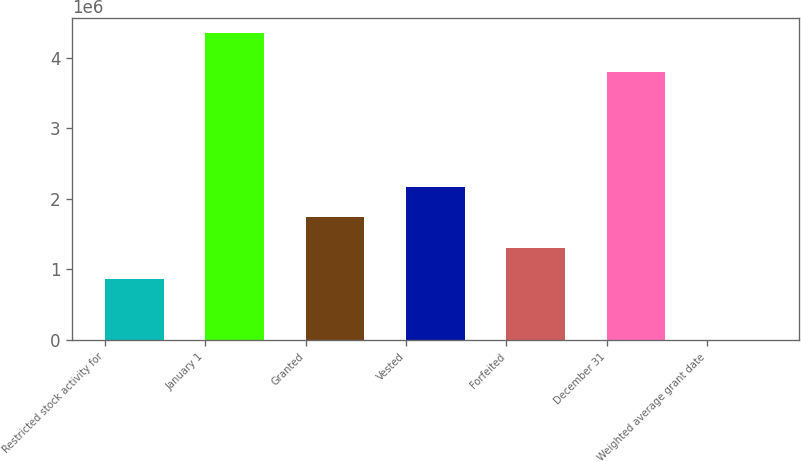Convert chart. <chart><loc_0><loc_0><loc_500><loc_500><bar_chart><fcel>Restricted stock activity for<fcel>January 1<fcel>Granted<fcel>Vested<fcel>Forfeited<fcel>December 31<fcel>Weighted average grant date<nl><fcel>869870<fcel>4.3491e+06<fcel>1.73968e+06<fcel>2.17458e+06<fcel>1.30477e+06<fcel>3.8021e+06<fcel>61.72<nl></chart> 